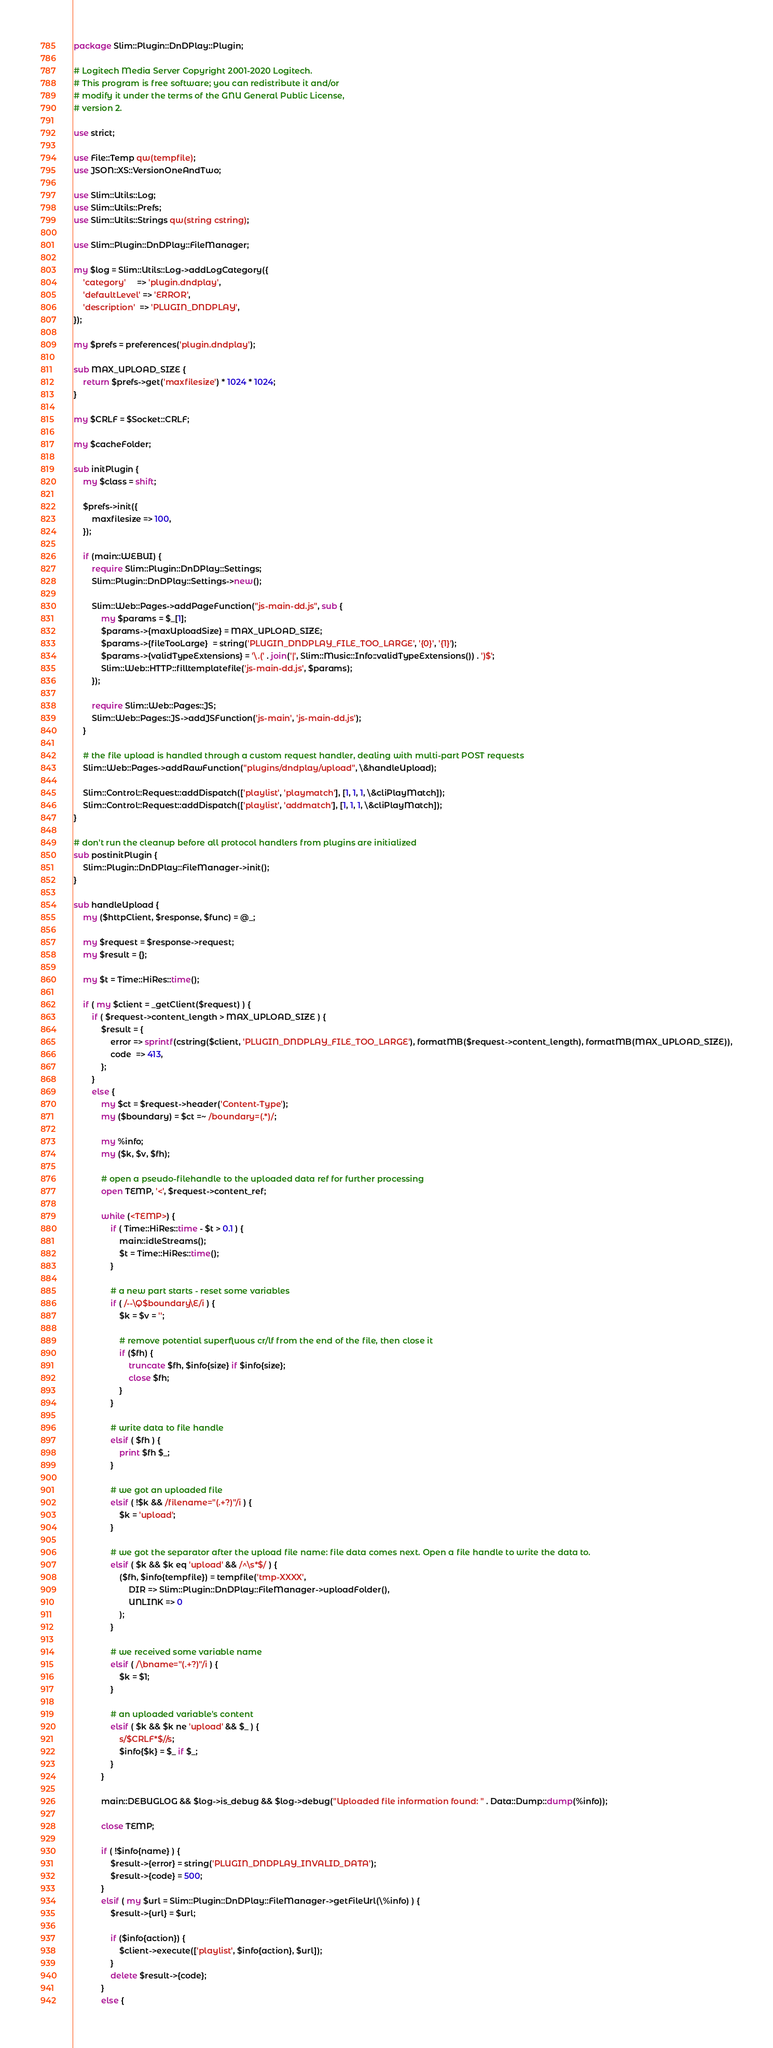<code> <loc_0><loc_0><loc_500><loc_500><_Perl_>package Slim::Plugin::DnDPlay::Plugin;

# Logitech Media Server Copyright 2001-2020 Logitech.
# This program is free software; you can redistribute it and/or
# modify it under the terms of the GNU General Public License,
# version 2.

use strict;

use File::Temp qw(tempfile);
use JSON::XS::VersionOneAndTwo;

use Slim::Utils::Log;
use Slim::Utils::Prefs;
use Slim::Utils::Strings qw(string cstring);

use Slim::Plugin::DnDPlay::FileManager;

my $log = Slim::Utils::Log->addLogCategory({
	'category'     => 'plugin.dndplay',
	'defaultLevel' => 'ERROR',
	'description'  => 'PLUGIN_DNDPLAY',
});

my $prefs = preferences('plugin.dndplay');

sub MAX_UPLOAD_SIZE {
	return $prefs->get('maxfilesize') * 1024 * 1024;
}

my $CRLF = $Socket::CRLF;

my $cacheFolder;

sub initPlugin {
	my $class = shift;

	$prefs->init({
		maxfilesize => 100,
	});
	
	if (main::WEBUI) {
		require Slim::Plugin::DnDPlay::Settings;
		Slim::Plugin::DnDPlay::Settings->new();
		
		Slim::Web::Pages->addPageFunction("js-main-dd.js", sub {
			my $params = $_[1];
			$params->{maxUploadSize} = MAX_UPLOAD_SIZE;
			$params->{fileTooLarge}  = string('PLUGIN_DNDPLAY_FILE_TOO_LARGE', '{0}', '{1}');
			$params->{validTypeExtensions} = '\.(' . join('|', Slim::Music::Info::validTypeExtensions()) . ')$';
			Slim::Web::HTTP::filltemplatefile('js-main-dd.js', $params);
		});

		require Slim::Web::Pages::JS;
		Slim::Web::Pages::JS->addJSFunction('js-main', 'js-main-dd.js');		
	} 
	
	# the file upload is handled through a custom request handler, dealing with multi-part POST requests
	Slim::Web::Pages->addRawFunction("plugins/dndplay/upload", \&handleUpload);
	
    Slim::Control::Request::addDispatch(['playlist', 'playmatch'], [1, 1, 1, \&cliPlayMatch]);
    Slim::Control::Request::addDispatch(['playlist', 'addmatch'], [1, 1, 1, \&cliPlayMatch]);
}

# don't run the cleanup before all protocol handlers from plugins are initialized
sub postinitPlugin {
	Slim::Plugin::DnDPlay::FileManager->init();
}

sub handleUpload {
	my ($httpClient, $response, $func) = @_;
	
	my $request = $response->request;
	my $result = {};
	
	my $t = Time::HiRes::time();
	
	if ( my $client = _getClient($request) ) {
		if ( $request->content_length > MAX_UPLOAD_SIZE ) {
			$result = {
				error => sprintf(cstring($client, 'PLUGIN_DNDPLAY_FILE_TOO_LARGE'), formatMB($request->content_length), formatMB(MAX_UPLOAD_SIZE)),
				code  => 413,
			};
		}
		else {
			my $ct = $request->header('Content-Type');
			my ($boundary) = $ct =~ /boundary=(.*)/;
			
			my %info;
			my ($k, $v, $fh);

			# open a pseudo-filehandle to the uploaded data ref for further processing
			open TEMP, '<', $request->content_ref;
			
			while (<TEMP>) {
				if ( Time::HiRes::time - $t > 0.1 ) {
					main::idleStreams();
					$t = Time::HiRes::time();
				}
				
				# a new part starts - reset some variables
				if ( /--\Q$boundary\E/i ) {
					$k = $v = '';
					
					# remove potential superfluous cr/lf from the end of the file, then close it
					if ($fh) {
						truncate $fh, $info{size} if $info{size};
						close $fh;
					}
				}
				
				# write data to file handle
				elsif ( $fh ) {
					print $fh $_;
				}
				
				# we got an uploaded file
				elsif ( !$k && /filename="(.+?)"/i ) {
					$k = 'upload';
				}
				
				# we got the separator after the upload file name: file data comes next. Open a file handle to write the data to.
				elsif ( $k && $k eq 'upload' && /^\s*$/ ) {
					($fh, $info{tempfile}) = tempfile('tmp-XXXX',
						DIR => Slim::Plugin::DnDPlay::FileManager->uploadFolder(),
						UNLINK => 0
					);
				}
				
				# we received some variable name
				elsif ( /\bname="(.+?)"/i ) {
					$k = $1;
				}
				
				# an uploaded variable's content
				elsif ( $k && $k ne 'upload' && $_ ) {
					s/$CRLF*$//s;
					$info{$k} = $_ if $_;
				}
			}
			
			main::DEBUGLOG && $log->is_debug && $log->debug("Uploaded file information found: " . Data::Dump::dump(%info));
			
			close TEMP;

			if ( !$info{name} ) {
				$result->{error} = string('PLUGIN_DNDPLAY_INVALID_DATA');
				$result->{code} = 500;
			}
			elsif ( my $url = Slim::Plugin::DnDPlay::FileManager->getFileUrl(\%info) ) {
				$result->{url} = $url;
				
				if ($info{action}) {
					$client->execute(['playlist', $info{action}, $url]);
				}
				delete $result->{code};
			}
			else {</code> 